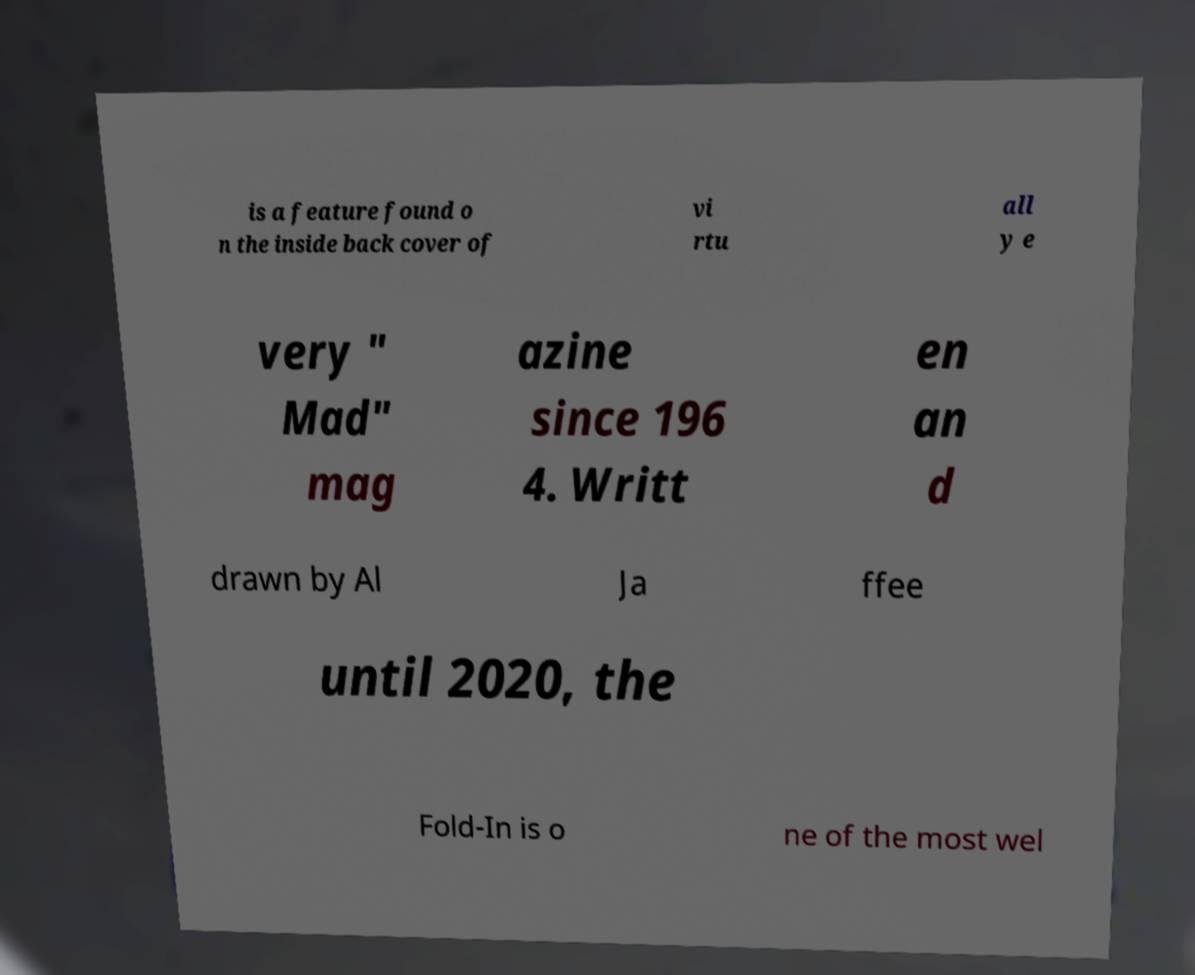Can you read and provide the text displayed in the image?This photo seems to have some interesting text. Can you extract and type it out for me? is a feature found o n the inside back cover of vi rtu all y e very " Mad" mag azine since 196 4. Writt en an d drawn by Al Ja ffee until 2020, the Fold-In is o ne of the most wel 